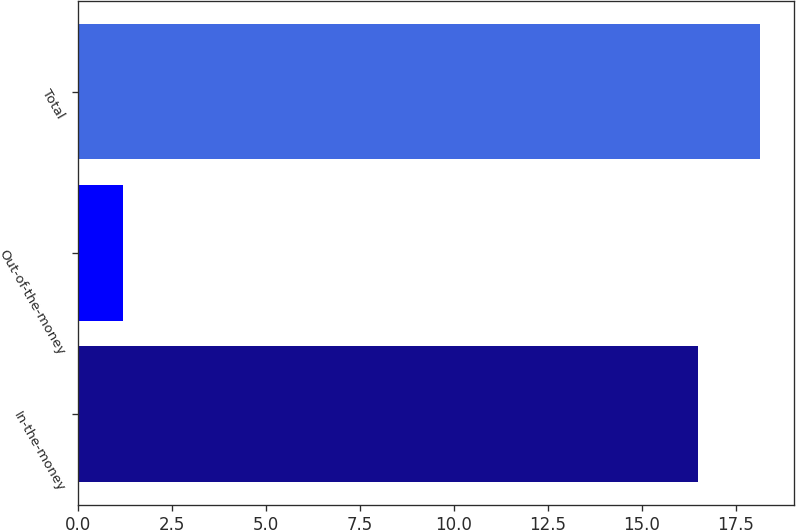<chart> <loc_0><loc_0><loc_500><loc_500><bar_chart><fcel>In-the-money<fcel>Out-of-the-money<fcel>Total<nl><fcel>16.5<fcel>1.2<fcel>18.15<nl></chart> 